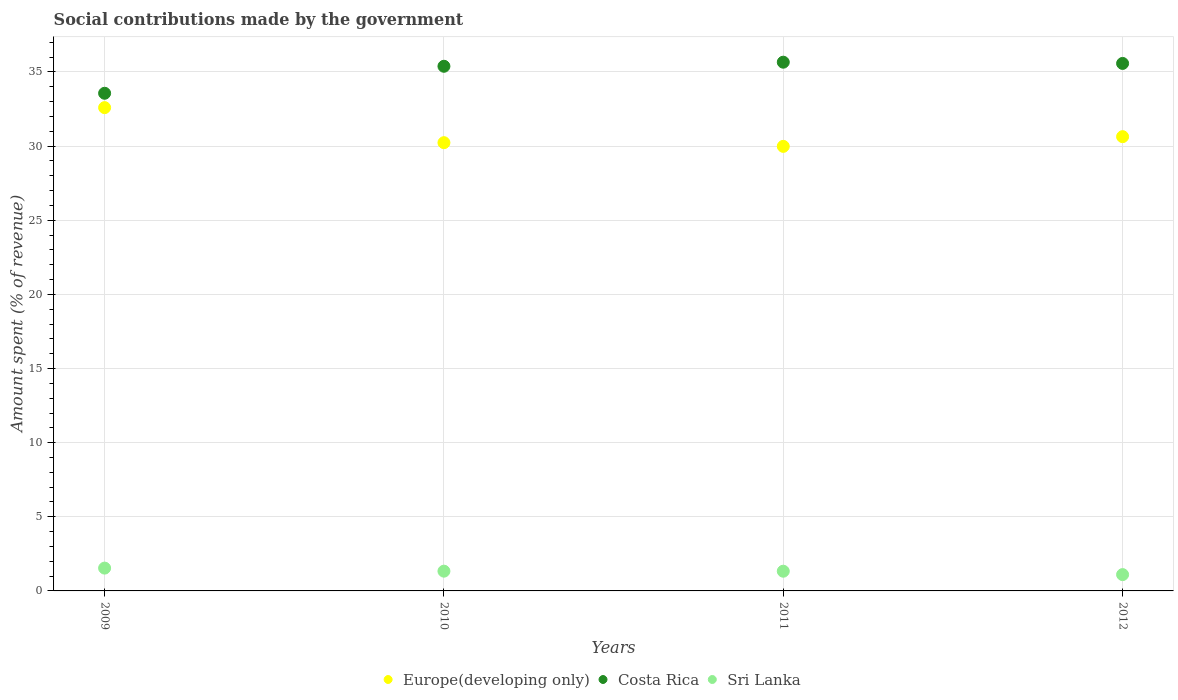How many different coloured dotlines are there?
Keep it short and to the point. 3. Is the number of dotlines equal to the number of legend labels?
Your response must be concise. Yes. What is the amount spent (in %) on social contributions in Costa Rica in 2011?
Offer a very short reply. 35.66. Across all years, what is the maximum amount spent (in %) on social contributions in Sri Lanka?
Ensure brevity in your answer.  1.54. Across all years, what is the minimum amount spent (in %) on social contributions in Sri Lanka?
Provide a succinct answer. 1.1. In which year was the amount spent (in %) on social contributions in Costa Rica maximum?
Your answer should be very brief. 2011. In which year was the amount spent (in %) on social contributions in Europe(developing only) minimum?
Your answer should be compact. 2011. What is the total amount spent (in %) on social contributions in Europe(developing only) in the graph?
Offer a terse response. 123.45. What is the difference between the amount spent (in %) on social contributions in Europe(developing only) in 2010 and that in 2012?
Your answer should be very brief. -0.41. What is the difference between the amount spent (in %) on social contributions in Costa Rica in 2011 and the amount spent (in %) on social contributions in Europe(developing only) in 2010?
Provide a succinct answer. 5.43. What is the average amount spent (in %) on social contributions in Costa Rica per year?
Ensure brevity in your answer.  35.05. In the year 2012, what is the difference between the amount spent (in %) on social contributions in Europe(developing only) and amount spent (in %) on social contributions in Sri Lanka?
Your answer should be compact. 29.54. In how many years, is the amount spent (in %) on social contributions in Sri Lanka greater than 20 %?
Provide a succinct answer. 0. What is the ratio of the amount spent (in %) on social contributions in Costa Rica in 2011 to that in 2012?
Your answer should be very brief. 1. What is the difference between the highest and the second highest amount spent (in %) on social contributions in Costa Rica?
Your answer should be compact. 0.08. What is the difference between the highest and the lowest amount spent (in %) on social contributions in Europe(developing only)?
Make the answer very short. 2.61. In how many years, is the amount spent (in %) on social contributions in Costa Rica greater than the average amount spent (in %) on social contributions in Costa Rica taken over all years?
Provide a short and direct response. 3. Is the sum of the amount spent (in %) on social contributions in Europe(developing only) in 2009 and 2011 greater than the maximum amount spent (in %) on social contributions in Costa Rica across all years?
Offer a very short reply. Yes. Is it the case that in every year, the sum of the amount spent (in %) on social contributions in Sri Lanka and amount spent (in %) on social contributions in Europe(developing only)  is greater than the amount spent (in %) on social contributions in Costa Rica?
Your answer should be compact. No. How many dotlines are there?
Your answer should be very brief. 3. How many years are there in the graph?
Provide a succinct answer. 4. What is the difference between two consecutive major ticks on the Y-axis?
Offer a terse response. 5. Does the graph contain grids?
Provide a short and direct response. Yes. Where does the legend appear in the graph?
Your answer should be very brief. Bottom center. What is the title of the graph?
Keep it short and to the point. Social contributions made by the government. What is the label or title of the X-axis?
Offer a terse response. Years. What is the label or title of the Y-axis?
Offer a very short reply. Amount spent (% of revenue). What is the Amount spent (% of revenue) in Europe(developing only) in 2009?
Provide a succinct answer. 32.6. What is the Amount spent (% of revenue) in Costa Rica in 2009?
Offer a terse response. 33.57. What is the Amount spent (% of revenue) in Sri Lanka in 2009?
Offer a terse response. 1.54. What is the Amount spent (% of revenue) of Europe(developing only) in 2010?
Provide a succinct answer. 30.23. What is the Amount spent (% of revenue) in Costa Rica in 2010?
Offer a terse response. 35.39. What is the Amount spent (% of revenue) of Sri Lanka in 2010?
Your answer should be very brief. 1.33. What is the Amount spent (% of revenue) of Europe(developing only) in 2011?
Ensure brevity in your answer.  29.98. What is the Amount spent (% of revenue) of Costa Rica in 2011?
Provide a short and direct response. 35.66. What is the Amount spent (% of revenue) of Sri Lanka in 2011?
Keep it short and to the point. 1.33. What is the Amount spent (% of revenue) in Europe(developing only) in 2012?
Your answer should be very brief. 30.64. What is the Amount spent (% of revenue) of Costa Rica in 2012?
Make the answer very short. 35.58. What is the Amount spent (% of revenue) of Sri Lanka in 2012?
Provide a short and direct response. 1.1. Across all years, what is the maximum Amount spent (% of revenue) of Europe(developing only)?
Your answer should be compact. 32.6. Across all years, what is the maximum Amount spent (% of revenue) of Costa Rica?
Make the answer very short. 35.66. Across all years, what is the maximum Amount spent (% of revenue) in Sri Lanka?
Provide a short and direct response. 1.54. Across all years, what is the minimum Amount spent (% of revenue) of Europe(developing only)?
Your answer should be very brief. 29.98. Across all years, what is the minimum Amount spent (% of revenue) in Costa Rica?
Your response must be concise. 33.57. Across all years, what is the minimum Amount spent (% of revenue) of Sri Lanka?
Your response must be concise. 1.1. What is the total Amount spent (% of revenue) of Europe(developing only) in the graph?
Keep it short and to the point. 123.45. What is the total Amount spent (% of revenue) in Costa Rica in the graph?
Make the answer very short. 140.19. What is the total Amount spent (% of revenue) in Sri Lanka in the graph?
Your answer should be very brief. 5.3. What is the difference between the Amount spent (% of revenue) in Europe(developing only) in 2009 and that in 2010?
Provide a succinct answer. 2.36. What is the difference between the Amount spent (% of revenue) of Costa Rica in 2009 and that in 2010?
Provide a succinct answer. -1.82. What is the difference between the Amount spent (% of revenue) in Sri Lanka in 2009 and that in 2010?
Provide a succinct answer. 0.21. What is the difference between the Amount spent (% of revenue) of Europe(developing only) in 2009 and that in 2011?
Offer a terse response. 2.61. What is the difference between the Amount spent (% of revenue) in Costa Rica in 2009 and that in 2011?
Provide a succinct answer. -2.1. What is the difference between the Amount spent (% of revenue) of Sri Lanka in 2009 and that in 2011?
Provide a succinct answer. 0.21. What is the difference between the Amount spent (% of revenue) in Europe(developing only) in 2009 and that in 2012?
Your response must be concise. 1.96. What is the difference between the Amount spent (% of revenue) in Costa Rica in 2009 and that in 2012?
Ensure brevity in your answer.  -2.01. What is the difference between the Amount spent (% of revenue) of Sri Lanka in 2009 and that in 2012?
Offer a terse response. 0.44. What is the difference between the Amount spent (% of revenue) of Europe(developing only) in 2010 and that in 2011?
Your response must be concise. 0.25. What is the difference between the Amount spent (% of revenue) in Costa Rica in 2010 and that in 2011?
Offer a terse response. -0.28. What is the difference between the Amount spent (% of revenue) of Sri Lanka in 2010 and that in 2011?
Offer a very short reply. 0. What is the difference between the Amount spent (% of revenue) in Europe(developing only) in 2010 and that in 2012?
Provide a succinct answer. -0.41. What is the difference between the Amount spent (% of revenue) in Costa Rica in 2010 and that in 2012?
Ensure brevity in your answer.  -0.19. What is the difference between the Amount spent (% of revenue) of Sri Lanka in 2010 and that in 2012?
Offer a very short reply. 0.23. What is the difference between the Amount spent (% of revenue) in Europe(developing only) in 2011 and that in 2012?
Your response must be concise. -0.65. What is the difference between the Amount spent (% of revenue) in Costa Rica in 2011 and that in 2012?
Offer a terse response. 0.08. What is the difference between the Amount spent (% of revenue) of Sri Lanka in 2011 and that in 2012?
Make the answer very short. 0.23. What is the difference between the Amount spent (% of revenue) in Europe(developing only) in 2009 and the Amount spent (% of revenue) in Costa Rica in 2010?
Offer a terse response. -2.79. What is the difference between the Amount spent (% of revenue) in Europe(developing only) in 2009 and the Amount spent (% of revenue) in Sri Lanka in 2010?
Your answer should be compact. 31.26. What is the difference between the Amount spent (% of revenue) of Costa Rica in 2009 and the Amount spent (% of revenue) of Sri Lanka in 2010?
Provide a short and direct response. 32.23. What is the difference between the Amount spent (% of revenue) of Europe(developing only) in 2009 and the Amount spent (% of revenue) of Costa Rica in 2011?
Your answer should be compact. -3.06. What is the difference between the Amount spent (% of revenue) in Europe(developing only) in 2009 and the Amount spent (% of revenue) in Sri Lanka in 2011?
Keep it short and to the point. 31.27. What is the difference between the Amount spent (% of revenue) of Costa Rica in 2009 and the Amount spent (% of revenue) of Sri Lanka in 2011?
Make the answer very short. 32.24. What is the difference between the Amount spent (% of revenue) of Europe(developing only) in 2009 and the Amount spent (% of revenue) of Costa Rica in 2012?
Make the answer very short. -2.98. What is the difference between the Amount spent (% of revenue) in Europe(developing only) in 2009 and the Amount spent (% of revenue) in Sri Lanka in 2012?
Ensure brevity in your answer.  31.5. What is the difference between the Amount spent (% of revenue) of Costa Rica in 2009 and the Amount spent (% of revenue) of Sri Lanka in 2012?
Make the answer very short. 32.47. What is the difference between the Amount spent (% of revenue) in Europe(developing only) in 2010 and the Amount spent (% of revenue) in Costa Rica in 2011?
Provide a succinct answer. -5.43. What is the difference between the Amount spent (% of revenue) of Europe(developing only) in 2010 and the Amount spent (% of revenue) of Sri Lanka in 2011?
Make the answer very short. 28.9. What is the difference between the Amount spent (% of revenue) of Costa Rica in 2010 and the Amount spent (% of revenue) of Sri Lanka in 2011?
Offer a terse response. 34.06. What is the difference between the Amount spent (% of revenue) in Europe(developing only) in 2010 and the Amount spent (% of revenue) in Costa Rica in 2012?
Offer a very short reply. -5.35. What is the difference between the Amount spent (% of revenue) in Europe(developing only) in 2010 and the Amount spent (% of revenue) in Sri Lanka in 2012?
Provide a succinct answer. 29.13. What is the difference between the Amount spent (% of revenue) in Costa Rica in 2010 and the Amount spent (% of revenue) in Sri Lanka in 2012?
Offer a very short reply. 34.29. What is the difference between the Amount spent (% of revenue) in Europe(developing only) in 2011 and the Amount spent (% of revenue) in Costa Rica in 2012?
Provide a short and direct response. -5.59. What is the difference between the Amount spent (% of revenue) in Europe(developing only) in 2011 and the Amount spent (% of revenue) in Sri Lanka in 2012?
Provide a short and direct response. 28.88. What is the difference between the Amount spent (% of revenue) in Costa Rica in 2011 and the Amount spent (% of revenue) in Sri Lanka in 2012?
Make the answer very short. 34.56. What is the average Amount spent (% of revenue) of Europe(developing only) per year?
Keep it short and to the point. 30.86. What is the average Amount spent (% of revenue) in Costa Rica per year?
Your answer should be compact. 35.05. What is the average Amount spent (% of revenue) in Sri Lanka per year?
Give a very brief answer. 1.33. In the year 2009, what is the difference between the Amount spent (% of revenue) of Europe(developing only) and Amount spent (% of revenue) of Costa Rica?
Give a very brief answer. -0.97. In the year 2009, what is the difference between the Amount spent (% of revenue) in Europe(developing only) and Amount spent (% of revenue) in Sri Lanka?
Your answer should be compact. 31.06. In the year 2009, what is the difference between the Amount spent (% of revenue) in Costa Rica and Amount spent (% of revenue) in Sri Lanka?
Make the answer very short. 32.03. In the year 2010, what is the difference between the Amount spent (% of revenue) in Europe(developing only) and Amount spent (% of revenue) in Costa Rica?
Your answer should be very brief. -5.15. In the year 2010, what is the difference between the Amount spent (% of revenue) in Europe(developing only) and Amount spent (% of revenue) in Sri Lanka?
Your answer should be compact. 28.9. In the year 2010, what is the difference between the Amount spent (% of revenue) of Costa Rica and Amount spent (% of revenue) of Sri Lanka?
Your response must be concise. 34.05. In the year 2011, what is the difference between the Amount spent (% of revenue) of Europe(developing only) and Amount spent (% of revenue) of Costa Rica?
Offer a terse response. -5.68. In the year 2011, what is the difference between the Amount spent (% of revenue) in Europe(developing only) and Amount spent (% of revenue) in Sri Lanka?
Your response must be concise. 28.65. In the year 2011, what is the difference between the Amount spent (% of revenue) in Costa Rica and Amount spent (% of revenue) in Sri Lanka?
Give a very brief answer. 34.33. In the year 2012, what is the difference between the Amount spent (% of revenue) in Europe(developing only) and Amount spent (% of revenue) in Costa Rica?
Keep it short and to the point. -4.94. In the year 2012, what is the difference between the Amount spent (% of revenue) of Europe(developing only) and Amount spent (% of revenue) of Sri Lanka?
Offer a terse response. 29.54. In the year 2012, what is the difference between the Amount spent (% of revenue) in Costa Rica and Amount spent (% of revenue) in Sri Lanka?
Keep it short and to the point. 34.48. What is the ratio of the Amount spent (% of revenue) in Europe(developing only) in 2009 to that in 2010?
Your answer should be compact. 1.08. What is the ratio of the Amount spent (% of revenue) of Costa Rica in 2009 to that in 2010?
Your response must be concise. 0.95. What is the ratio of the Amount spent (% of revenue) of Sri Lanka in 2009 to that in 2010?
Your answer should be very brief. 1.15. What is the ratio of the Amount spent (% of revenue) of Europe(developing only) in 2009 to that in 2011?
Your answer should be compact. 1.09. What is the ratio of the Amount spent (% of revenue) of Costa Rica in 2009 to that in 2011?
Your response must be concise. 0.94. What is the ratio of the Amount spent (% of revenue) of Sri Lanka in 2009 to that in 2011?
Your response must be concise. 1.16. What is the ratio of the Amount spent (% of revenue) of Europe(developing only) in 2009 to that in 2012?
Give a very brief answer. 1.06. What is the ratio of the Amount spent (% of revenue) in Costa Rica in 2009 to that in 2012?
Provide a short and direct response. 0.94. What is the ratio of the Amount spent (% of revenue) in Sri Lanka in 2009 to that in 2012?
Provide a succinct answer. 1.4. What is the ratio of the Amount spent (% of revenue) of Europe(developing only) in 2010 to that in 2011?
Ensure brevity in your answer.  1.01. What is the ratio of the Amount spent (% of revenue) in Sri Lanka in 2010 to that in 2011?
Offer a terse response. 1. What is the ratio of the Amount spent (% of revenue) in Sri Lanka in 2010 to that in 2012?
Make the answer very short. 1.21. What is the ratio of the Amount spent (% of revenue) in Europe(developing only) in 2011 to that in 2012?
Keep it short and to the point. 0.98. What is the ratio of the Amount spent (% of revenue) of Sri Lanka in 2011 to that in 2012?
Give a very brief answer. 1.21. What is the difference between the highest and the second highest Amount spent (% of revenue) in Europe(developing only)?
Your answer should be compact. 1.96. What is the difference between the highest and the second highest Amount spent (% of revenue) in Costa Rica?
Your response must be concise. 0.08. What is the difference between the highest and the second highest Amount spent (% of revenue) in Sri Lanka?
Your answer should be very brief. 0.21. What is the difference between the highest and the lowest Amount spent (% of revenue) in Europe(developing only)?
Ensure brevity in your answer.  2.61. What is the difference between the highest and the lowest Amount spent (% of revenue) of Costa Rica?
Make the answer very short. 2.1. What is the difference between the highest and the lowest Amount spent (% of revenue) in Sri Lanka?
Offer a very short reply. 0.44. 